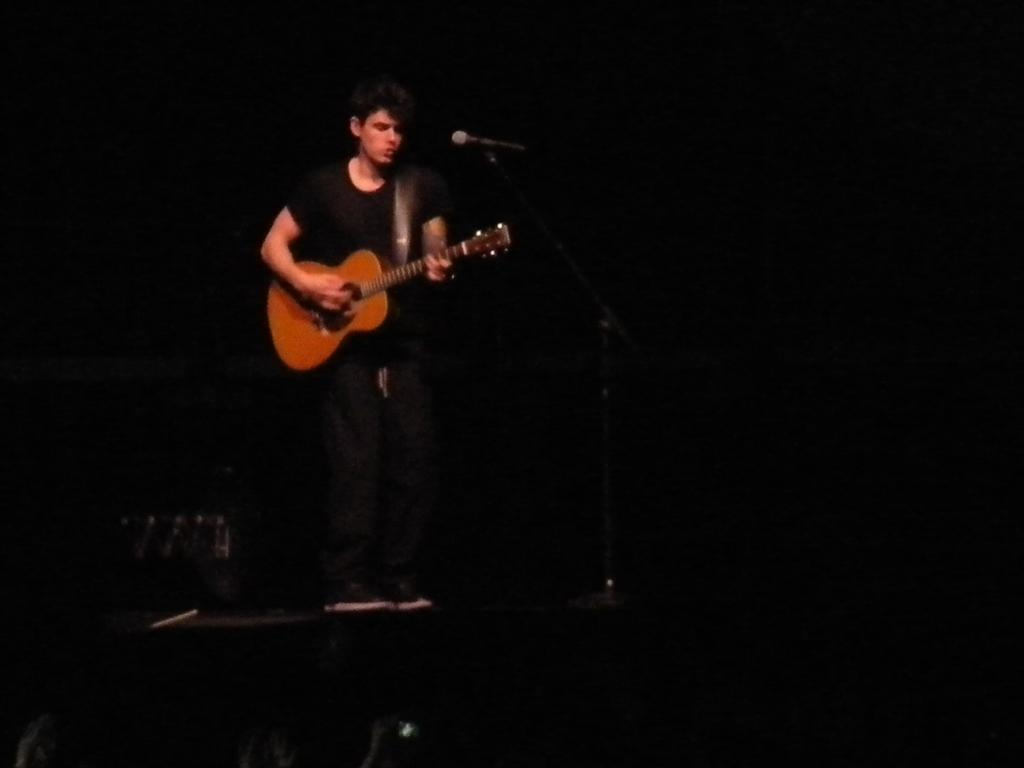What is the man in the image doing? The man is playing a guitar. What is the man wearing in the image? The man is wearing a black dress. What object is in front of the man? There is a microphone in front of the man. What type of army is visible in the image? There is no army present in the image. What type of care is the man providing to the stone in the image? There is no stone present in the image, and therefore no care is being provided. 